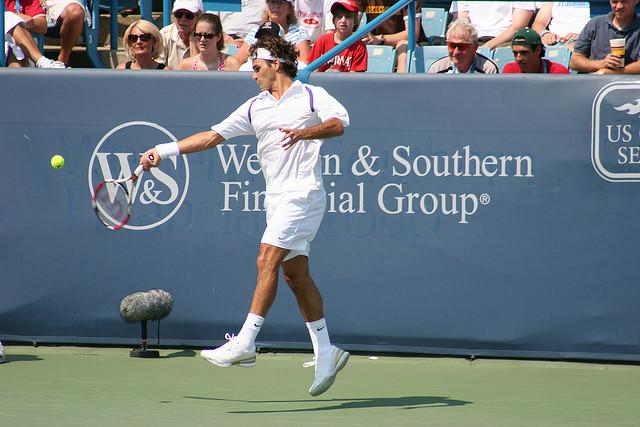What is traveling towards the man?

Choices:
A) tennis ball
B) dog
C) cow
D) bee tennis ball 